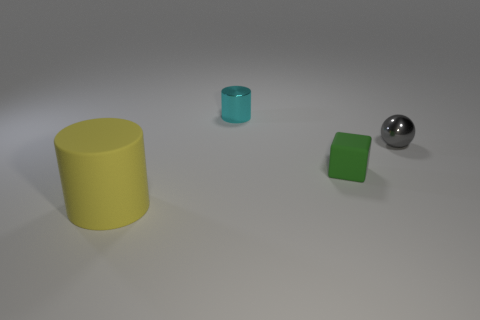Add 2 tiny brown rubber cylinders. How many objects exist? 6 Subtract all blocks. How many objects are left? 3 Add 4 small cylinders. How many small cylinders are left? 5 Add 1 yellow matte cylinders. How many yellow matte cylinders exist? 2 Subtract 0 cyan cubes. How many objects are left? 4 Subtract all gray balls. Subtract all gray metallic things. How many objects are left? 2 